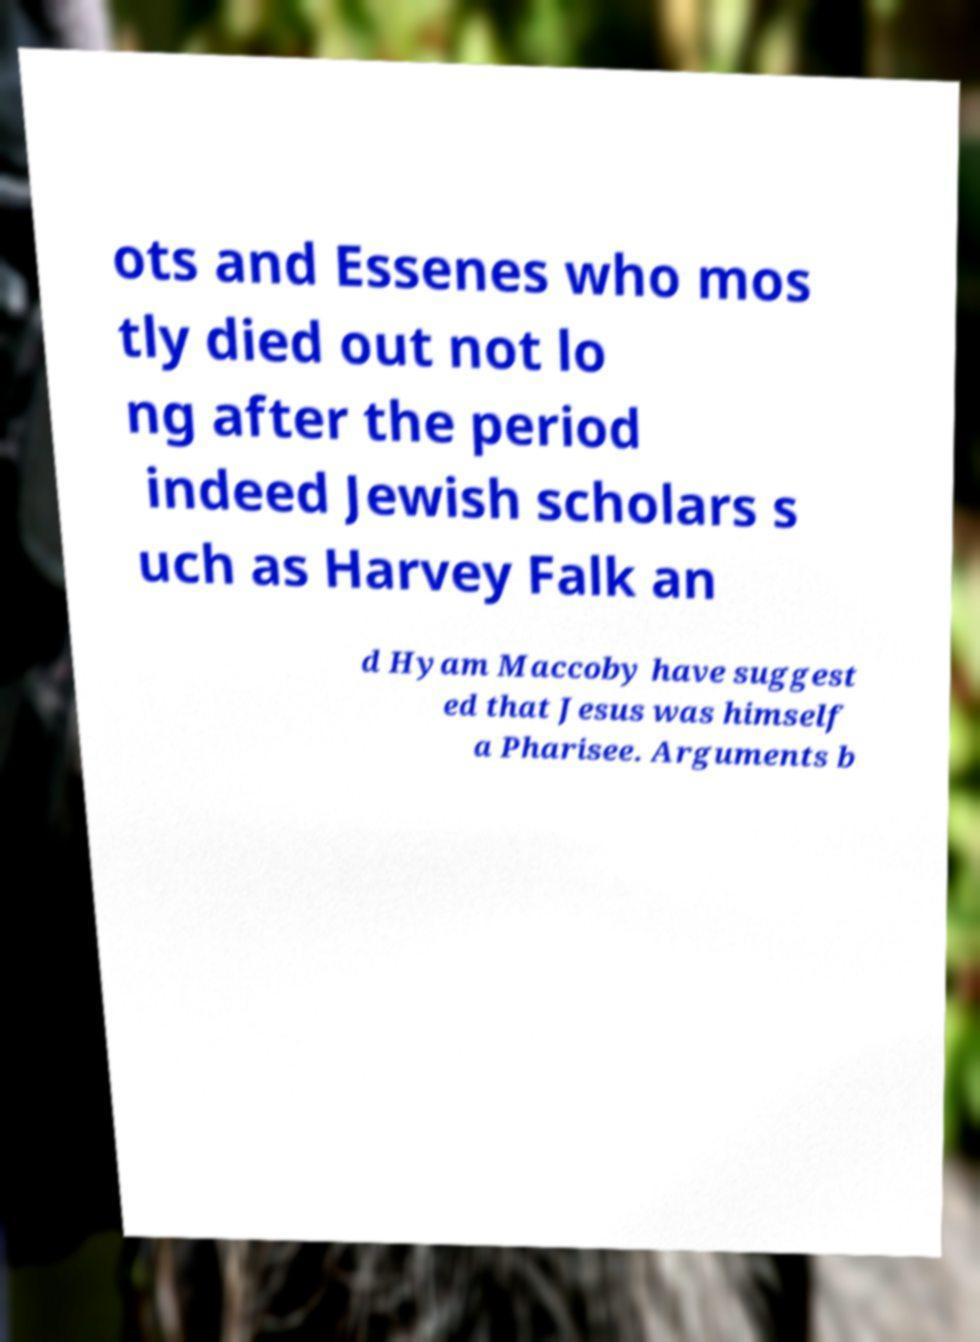Can you read and provide the text displayed in the image?This photo seems to have some interesting text. Can you extract and type it out for me? ots and Essenes who mos tly died out not lo ng after the period indeed Jewish scholars s uch as Harvey Falk an d Hyam Maccoby have suggest ed that Jesus was himself a Pharisee. Arguments b 